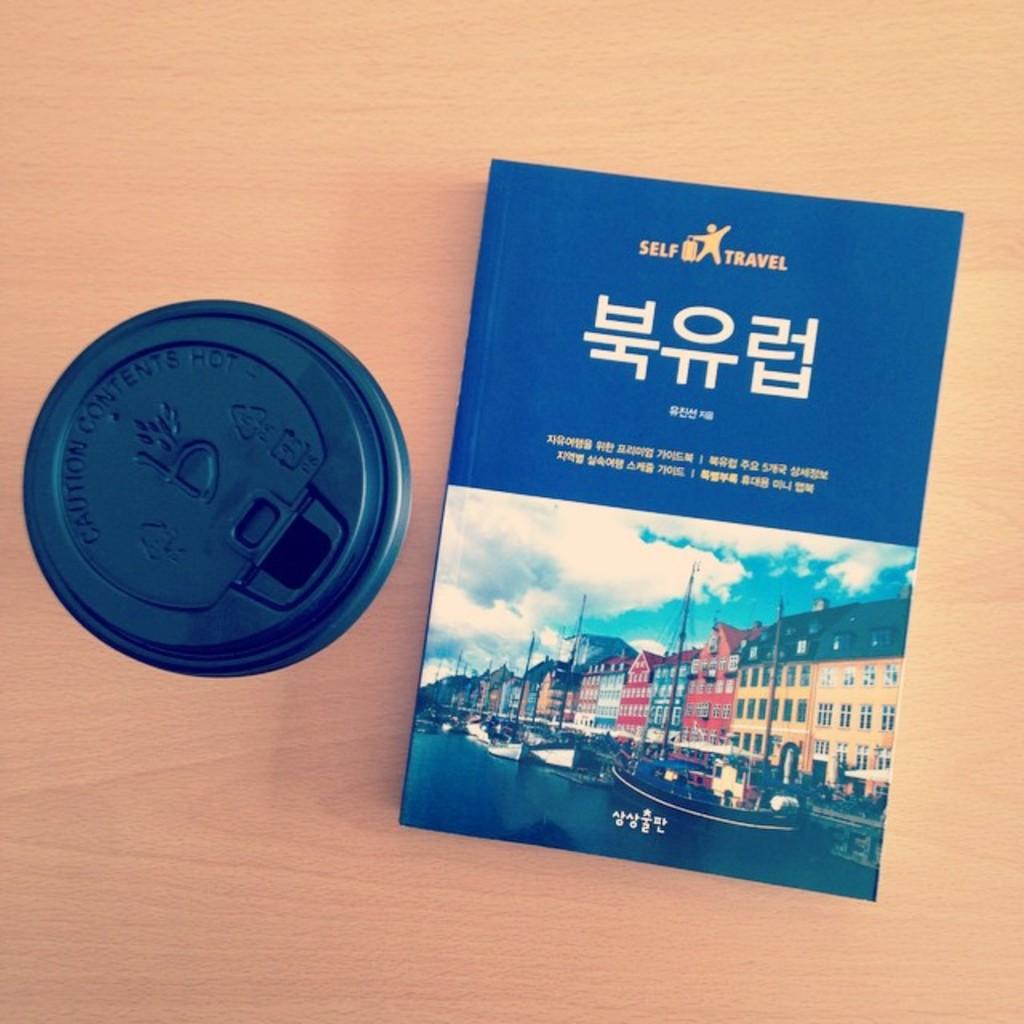Provide a one-sentence caption for the provided image. A HARD COVER ORIENTAL BOOK FOR THE SELF TRAVELER. 